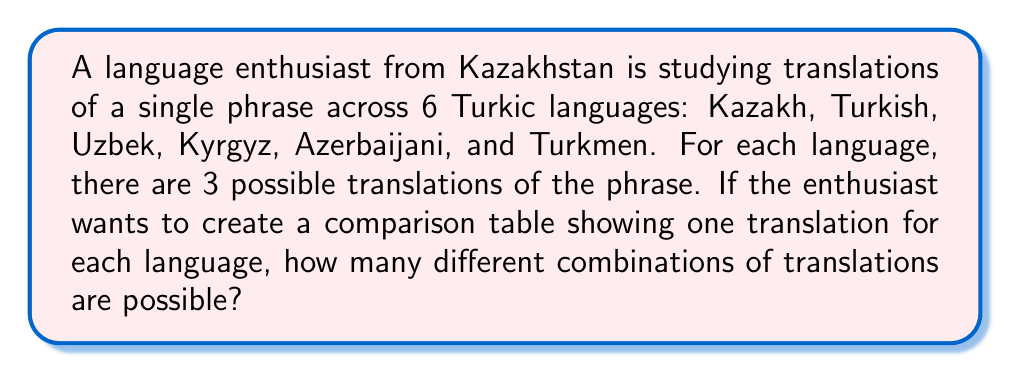Help me with this question. Let's approach this step-by-step:

1) We have 6 Turkic languages, and for each language, we need to choose 1 translation out of 3 possible translations.

2) This is a perfect scenario for applying the multiplication principle in combinatorics.

3) For each language, we have 3 choices, and this is independent of the choices for other languages.

4) Therefore, we multiply the number of choices for each language:

   $$ 3 \times 3 \times 3 \times 3 \times 3 \times 3 $$

5) This can be written more concisely as:

   $$ 3^6 $$

6) Calculating this:
   $$ 3^6 = 3 \times 3 \times 3 \times 3 \times 3 \times 3 = 729 $$

Thus, there are 729 different possible combinations of translations for the comparison table.
Answer: $729$ 